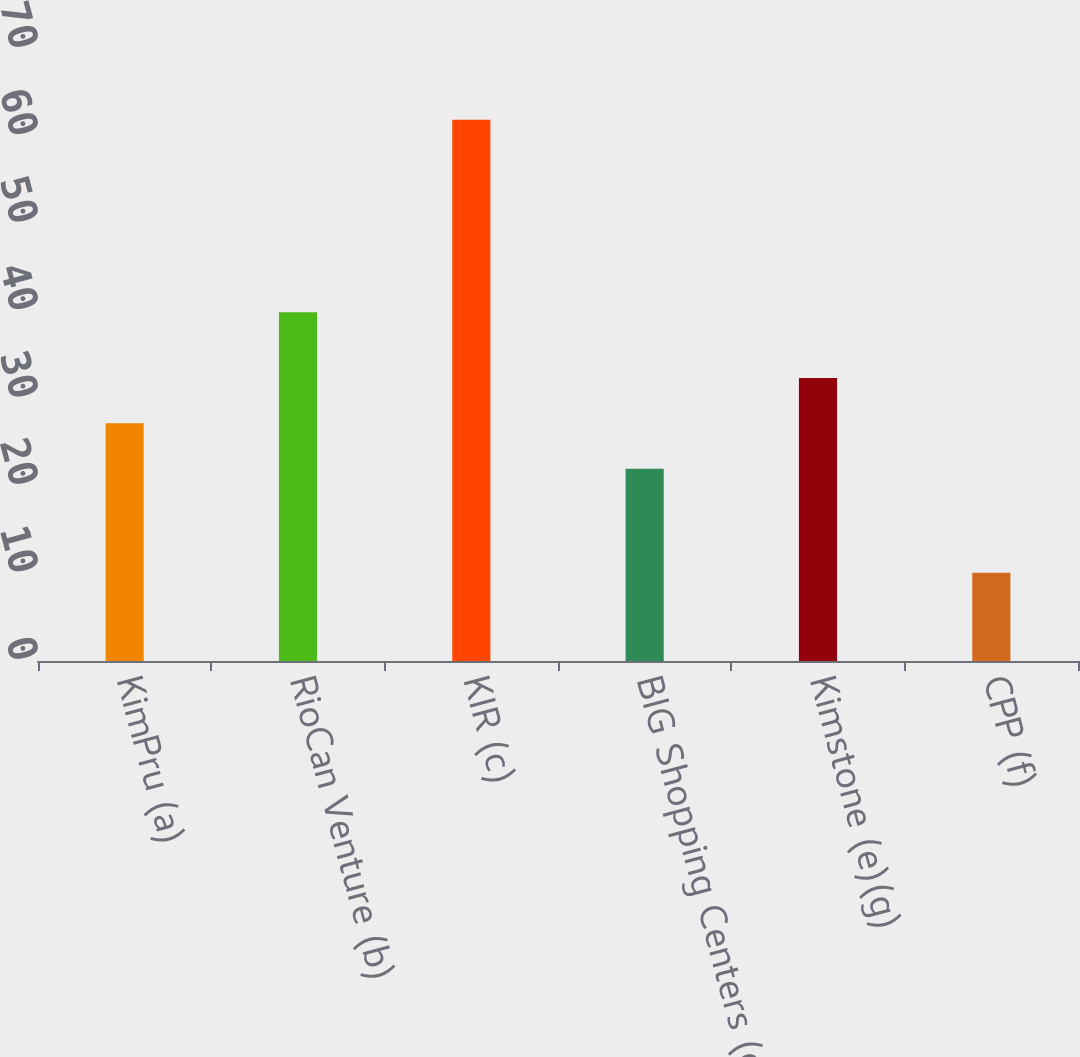Convert chart to OTSL. <chart><loc_0><loc_0><loc_500><loc_500><bar_chart><fcel>KimPru (a)<fcel>RioCan Venture (b)<fcel>KIR (c)<fcel>BIG Shopping Centers (d)<fcel>Kimstone (e)(g)<fcel>CPP (f)<nl><fcel>27.18<fcel>39.9<fcel>61.9<fcel>22<fcel>32.36<fcel>10.1<nl></chart> 